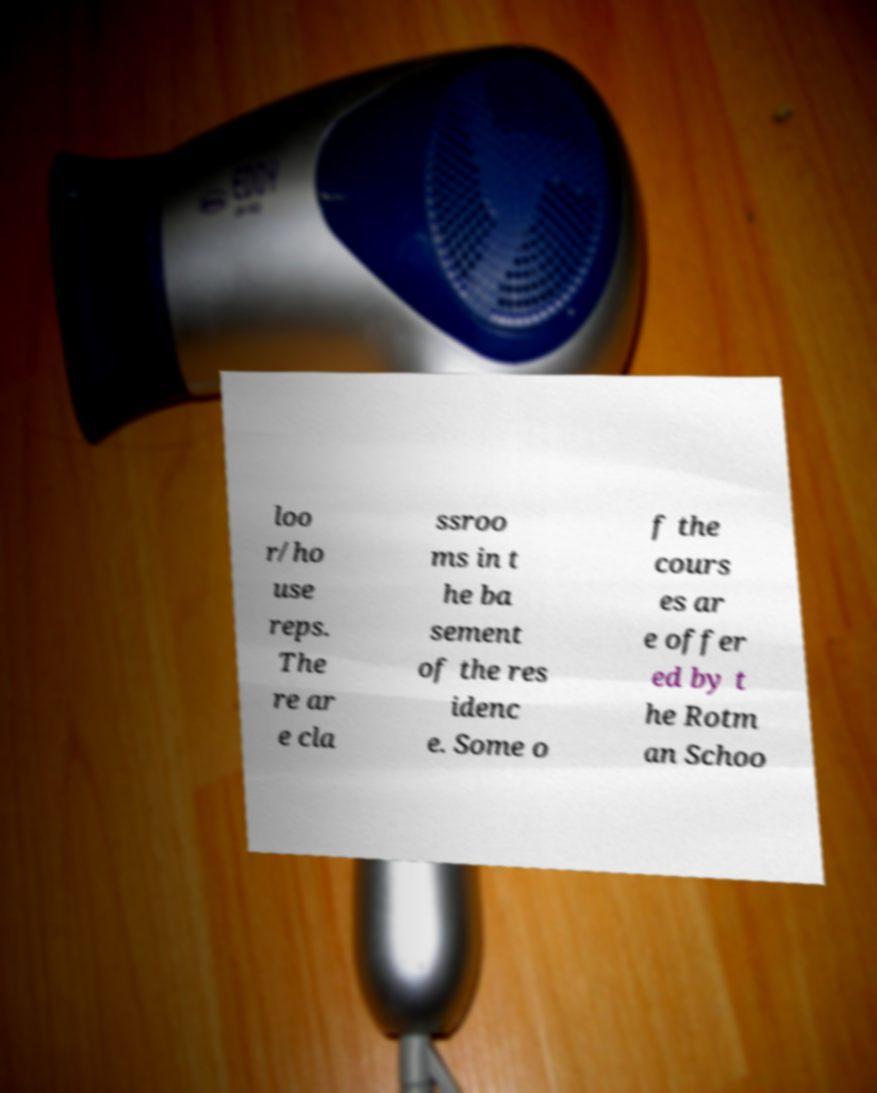There's text embedded in this image that I need extracted. Can you transcribe it verbatim? loo r/ho use reps. The re ar e cla ssroo ms in t he ba sement of the res idenc e. Some o f the cours es ar e offer ed by t he Rotm an Schoo 